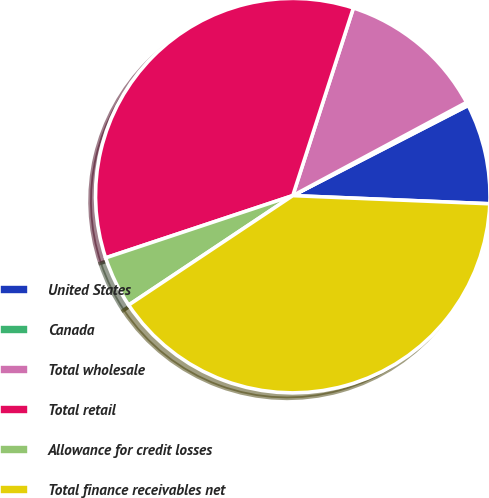<chart> <loc_0><loc_0><loc_500><loc_500><pie_chart><fcel>United States<fcel>Canada<fcel>Total wholesale<fcel>Total retail<fcel>Allowance for credit losses<fcel>Total finance receivables net<nl><fcel>8.22%<fcel>0.28%<fcel>12.19%<fcel>35.09%<fcel>4.25%<fcel>39.99%<nl></chart> 